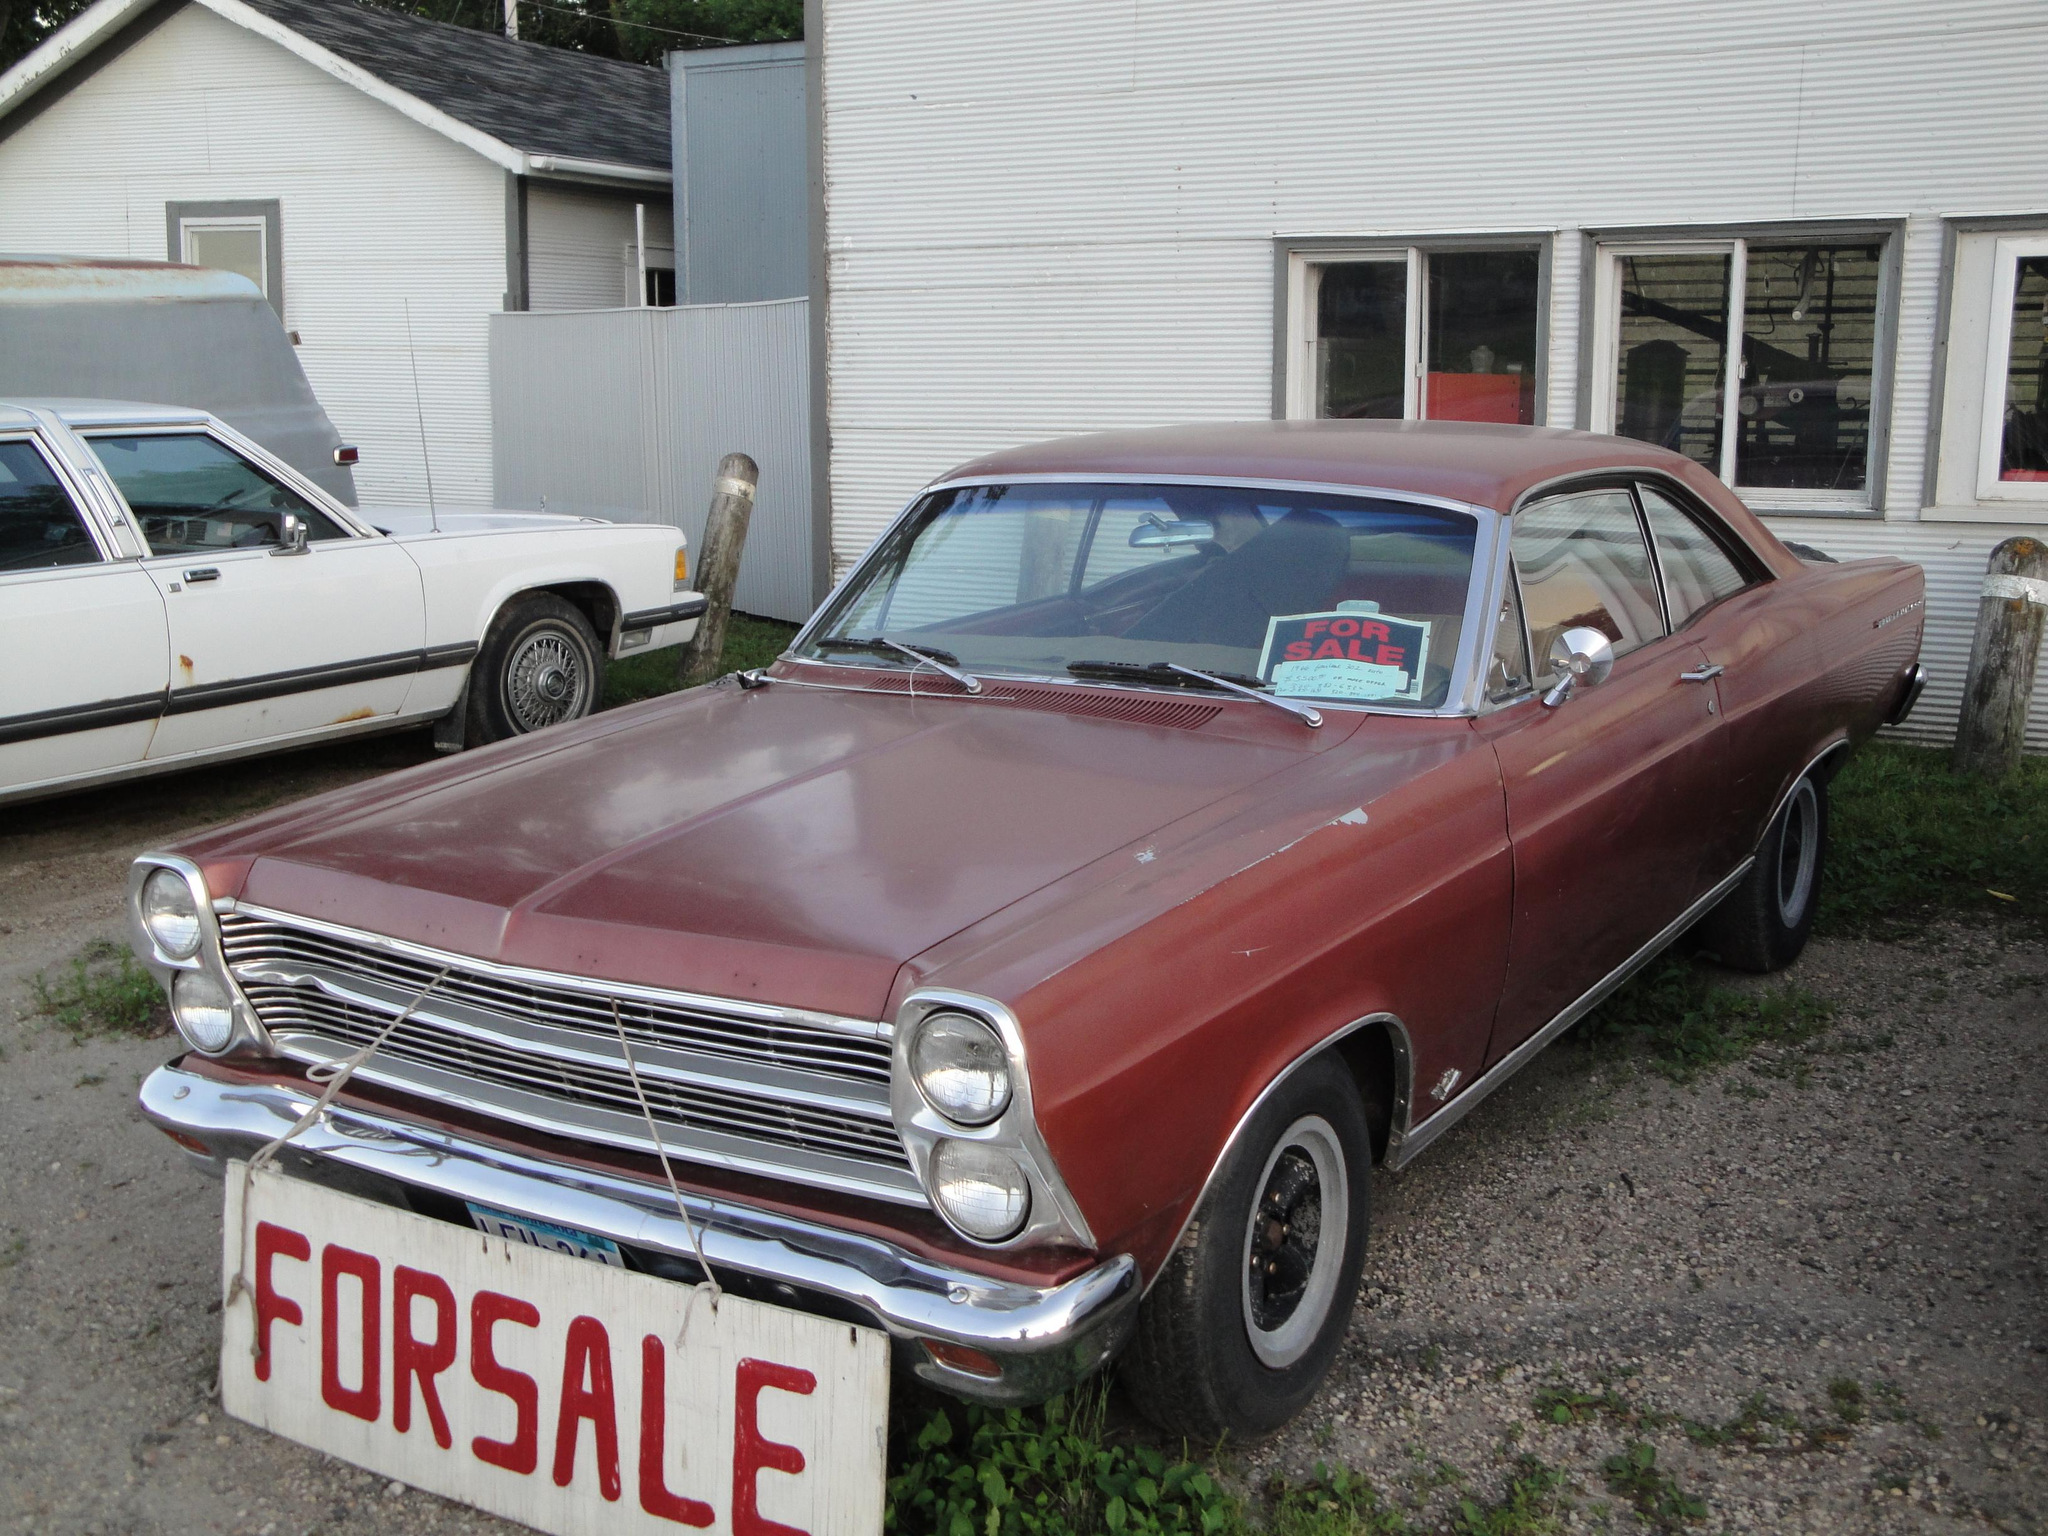What types of vehicles can be seen in the image? There are vehicles in the image, but the specific types are not mentioned. What is the ground surface like in the image? Grass is present on the ground in the image. What can be seen in the background of the image? There are shelters visible in the background of the image. What type of fear is depicted in the image? There is no fear depicted in the image; it features vehicles, grass, and shelters. How many knots are tied in the image? There are no knots present in the image. 